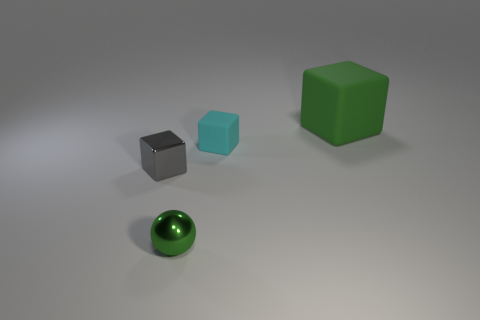Subtract all small gray blocks. How many blocks are left? 2 Subtract all green cubes. How many cubes are left? 2 Add 2 cyan objects. How many objects exist? 6 Subtract all cubes. How many objects are left? 1 Subtract all cyan cylinders. How many gray cubes are left? 1 Add 4 tiny green things. How many tiny green things are left? 5 Add 2 balls. How many balls exist? 3 Subtract 0 blue cubes. How many objects are left? 4 Subtract all red blocks. Subtract all cyan cylinders. How many blocks are left? 3 Subtract all small shiny objects. Subtract all tiny gray blocks. How many objects are left? 1 